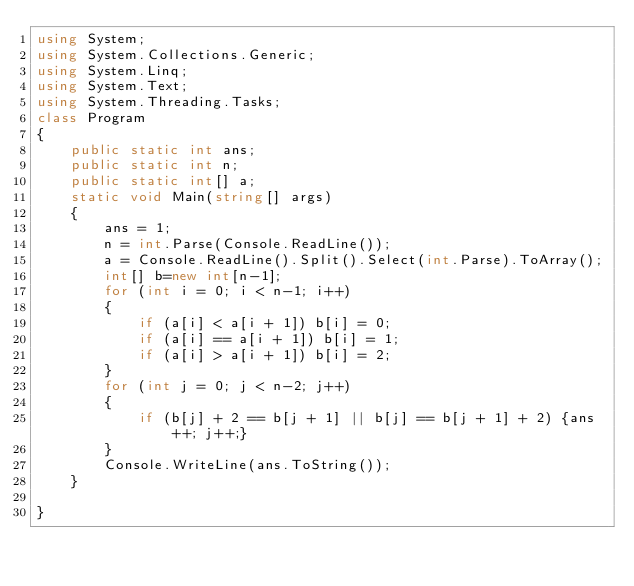Convert code to text. <code><loc_0><loc_0><loc_500><loc_500><_C#_>using System;
using System.Collections.Generic;
using System.Linq;
using System.Text;
using System.Threading.Tasks;
class Program
{
    public static int ans;
    public static int n;
    public static int[] a;
    static void Main(string[] args)
    {
        ans = 1;
        n = int.Parse(Console.ReadLine());
        a = Console.ReadLine().Split().Select(int.Parse).ToArray();
        int[] b=new int[n-1];
        for (int i = 0; i < n-1; i++)
        {
            if (a[i] < a[i + 1]) b[i] = 0;
            if (a[i] == a[i + 1]) b[i] = 1;
            if (a[i] > a[i + 1]) b[i] = 2;
        }
        for (int j = 0; j < n-2; j++)
        {
            if (b[j] + 2 == b[j + 1] || b[j] == b[j + 1] + 2) {ans++; j++;}
        }
        Console.WriteLine(ans.ToString());
    }
    
}</code> 